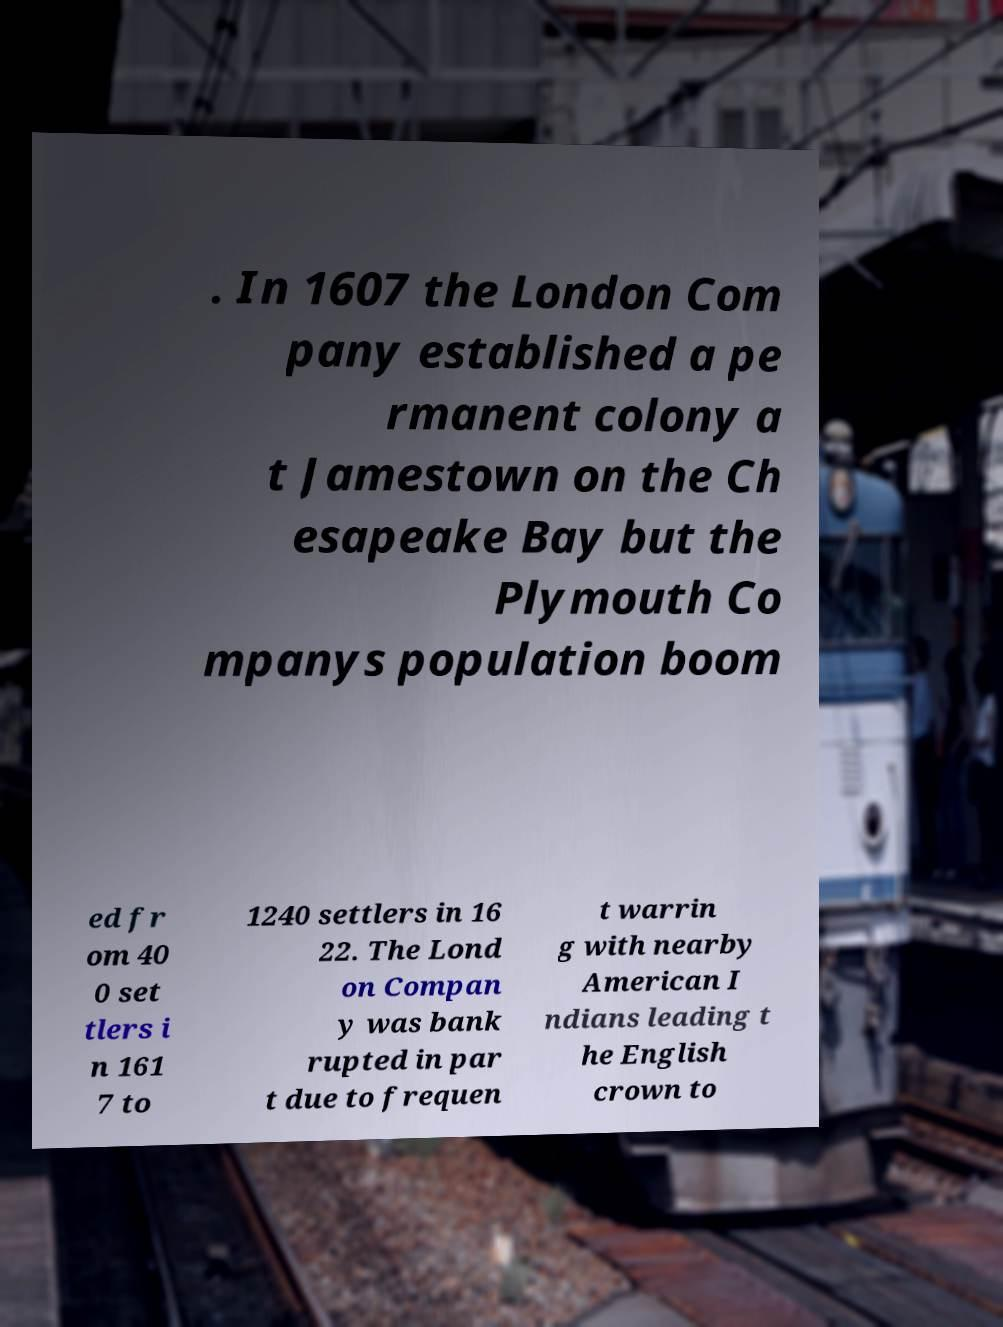Can you accurately transcribe the text from the provided image for me? . In 1607 the London Com pany established a pe rmanent colony a t Jamestown on the Ch esapeake Bay but the Plymouth Co mpanys population boom ed fr om 40 0 set tlers i n 161 7 to 1240 settlers in 16 22. The Lond on Compan y was bank rupted in par t due to frequen t warrin g with nearby American I ndians leading t he English crown to 